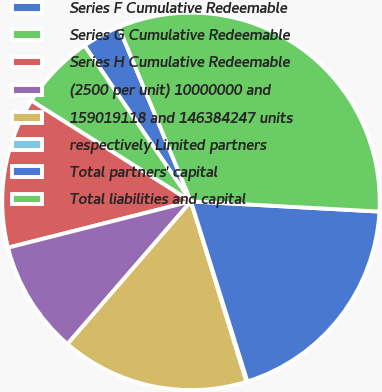Convert chart. <chart><loc_0><loc_0><loc_500><loc_500><pie_chart><fcel>Series F Cumulative Redeemable<fcel>Series G Cumulative Redeemable<fcel>Series H Cumulative Redeemable<fcel>(2500 per unit) 10000000 and<fcel>159019118 and 146384247 units<fcel>respectively Limited partners<fcel>Total partners' capital<fcel>Total liabilities and capital<nl><fcel>3.29%<fcel>6.5%<fcel>12.9%<fcel>9.7%<fcel>16.1%<fcel>0.09%<fcel>19.3%<fcel>32.11%<nl></chart> 